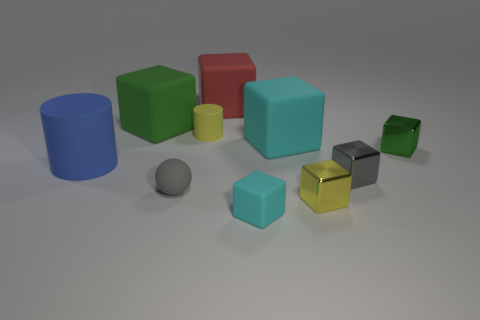There is a metallic cube that is on the left side of the gray block; is it the same size as the cyan cube that is behind the green shiny object?
Your response must be concise. No. Are there fewer tiny spheres right of the small rubber cube than small matte blocks on the right side of the gray rubber ball?
Make the answer very short. Yes. There is a thing that is the same color as the tiny rubber block; what material is it?
Offer a very short reply. Rubber. The small sphere on the left side of the small green cube is what color?
Offer a terse response. Gray. Is the tiny cylinder the same color as the rubber sphere?
Keep it short and to the point. No. There is a cyan block that is behind the small gray object on the left side of the large red rubber object; how many yellow things are in front of it?
Your answer should be very brief. 1. What is the size of the blue rubber cylinder?
Give a very brief answer. Large. There is a cyan object that is the same size as the yellow matte object; what material is it?
Your answer should be compact. Rubber. There is a tiny gray metallic thing; what number of yellow things are behind it?
Give a very brief answer. 1. Is the cyan object on the right side of the small matte block made of the same material as the tiny object on the right side of the small gray shiny thing?
Make the answer very short. No. 